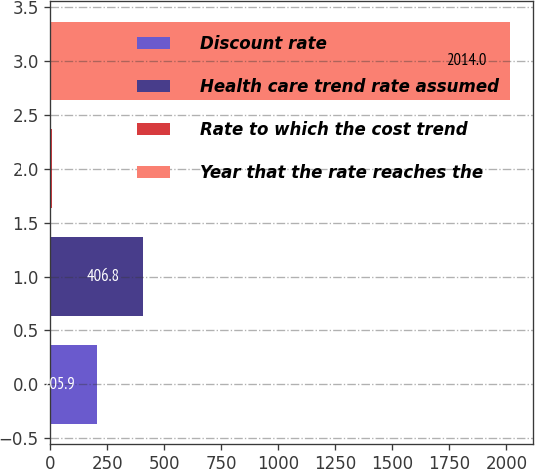<chart> <loc_0><loc_0><loc_500><loc_500><bar_chart><fcel>Discount rate<fcel>Health care trend rate assumed<fcel>Rate to which the cost trend<fcel>Year that the rate reaches the<nl><fcel>205.9<fcel>406.8<fcel>5<fcel>2014<nl></chart> 